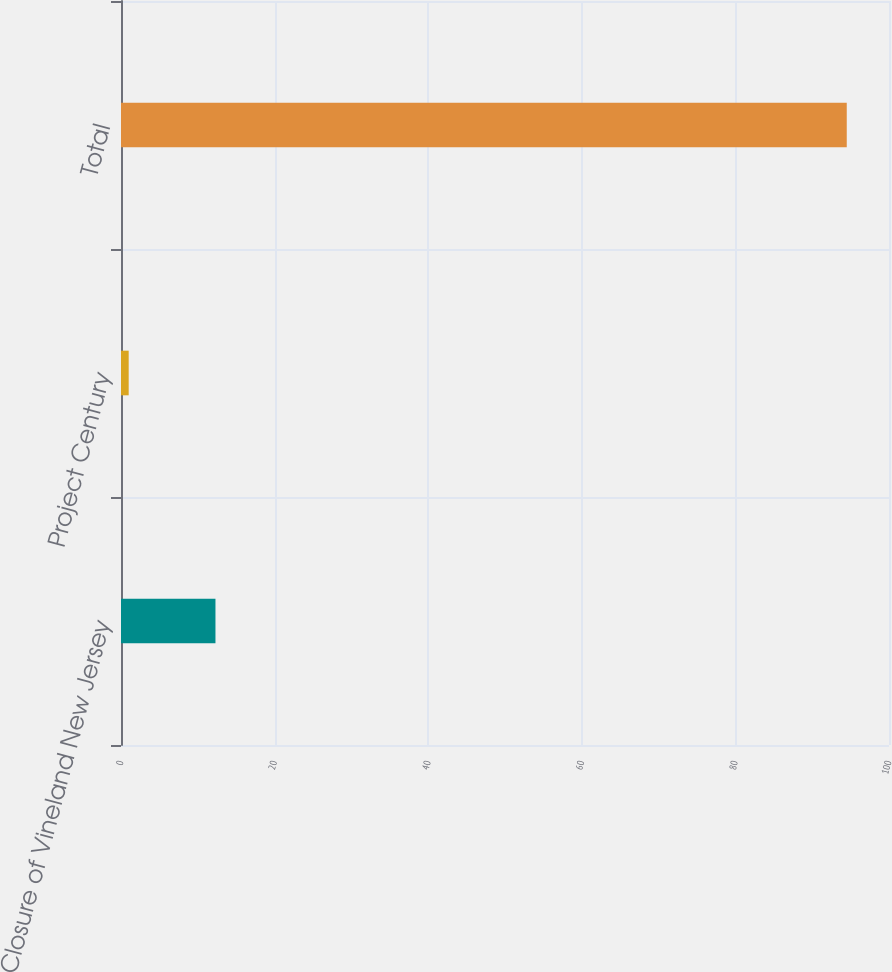Convert chart. <chart><loc_0><loc_0><loc_500><loc_500><bar_chart><fcel>Closure of Vineland New Jersey<fcel>Project Century<fcel>Total<nl><fcel>12.3<fcel>1<fcel>94.5<nl></chart> 